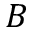<formula> <loc_0><loc_0><loc_500><loc_500>B</formula> 